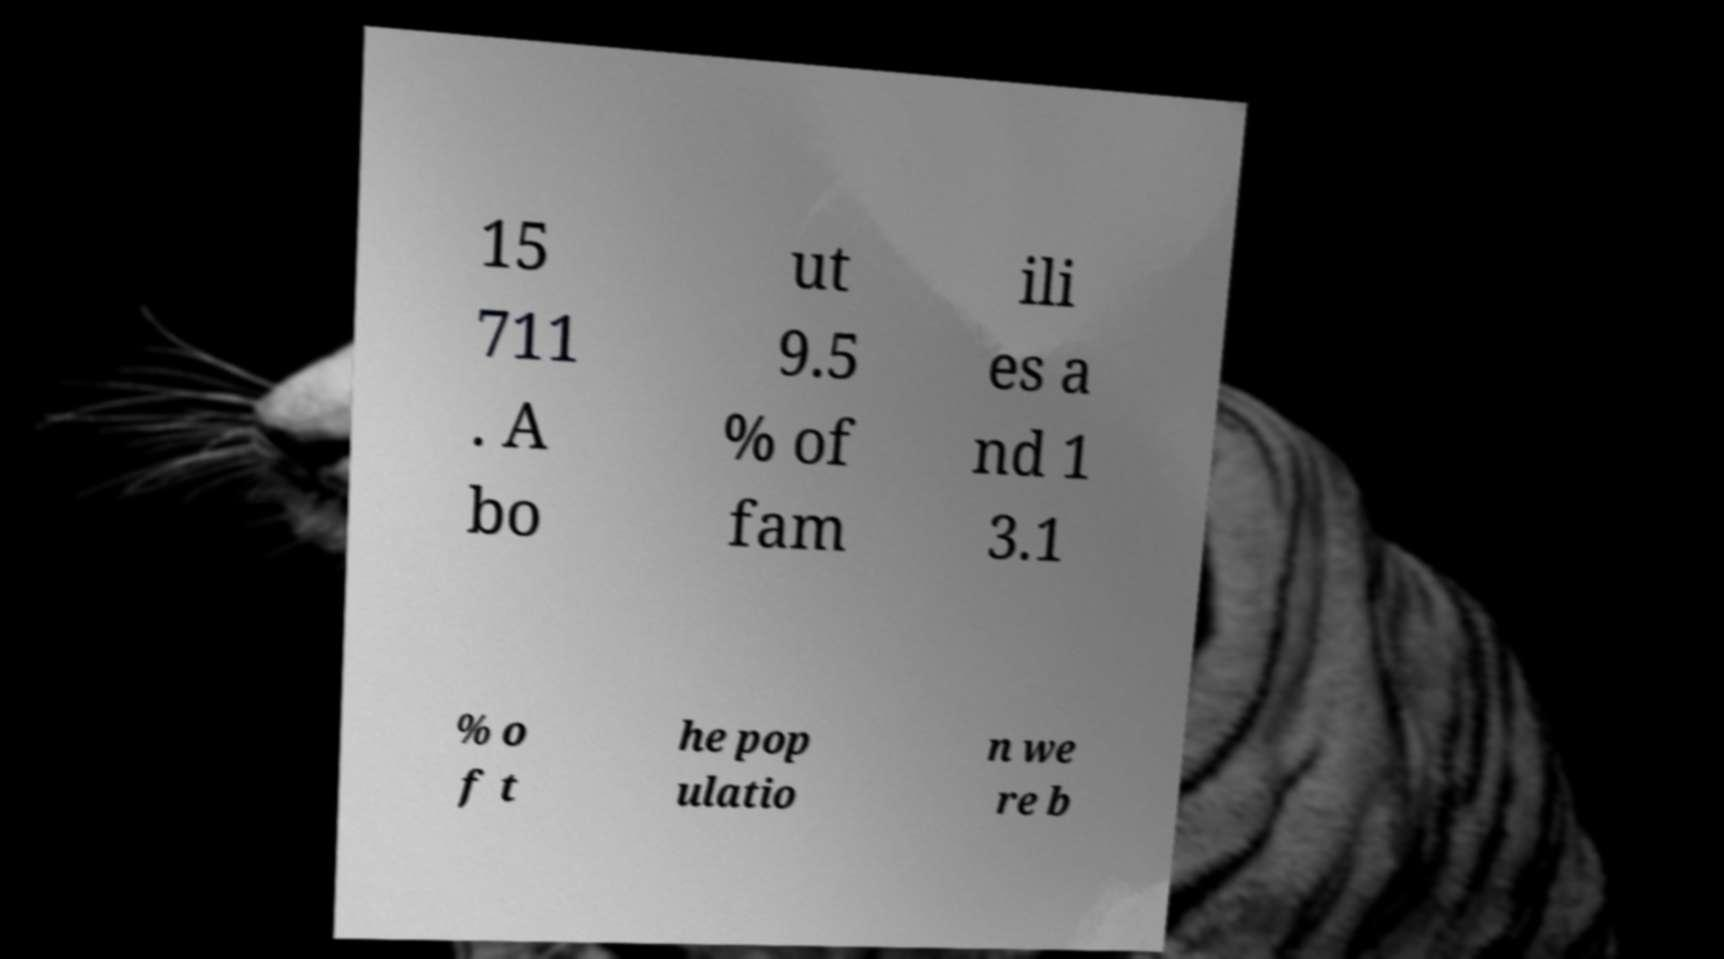There's text embedded in this image that I need extracted. Can you transcribe it verbatim? 15 711 . A bo ut 9.5 % of fam ili es a nd 1 3.1 % o f t he pop ulatio n we re b 